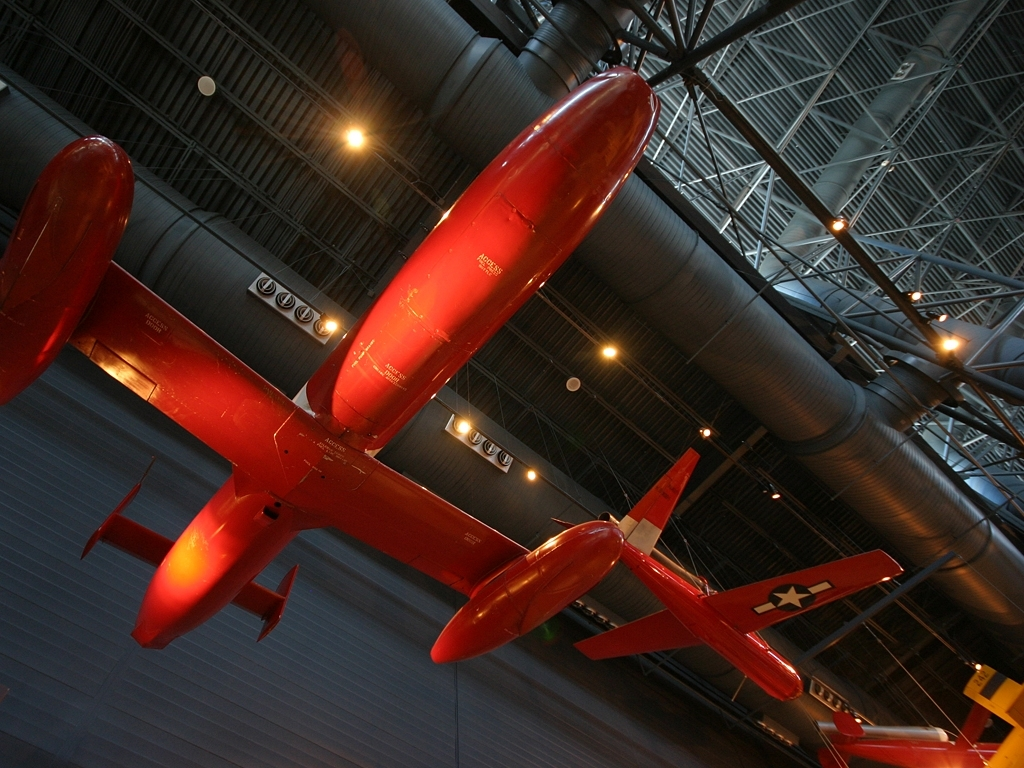What is the quality of this image? The image is of good quality, with sufficient lighting and sharpness to make out the details of the red aircraft and the environment it's displayed in, like the structure of the museum and other aircraft in the background. The perspective used in the photograph provides a dynamic angle, showcasing the design and features of the aircraft effectively. 